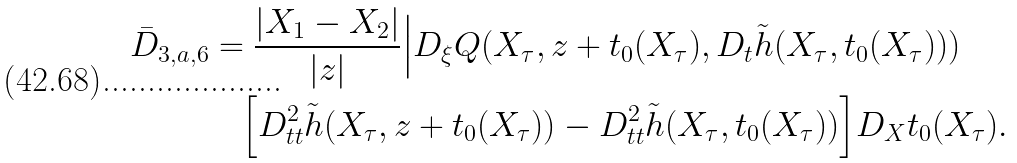Convert formula to latex. <formula><loc_0><loc_0><loc_500><loc_500>\bar { D } _ { 3 , a , 6 } & = \frac { | X _ { 1 } - X _ { 2 } | } { | z | } \Big | D _ { \xi } Q ( X _ { \tau } , z + t _ { 0 } ( X _ { \tau } ) , D _ { t } \tilde { h } ( X _ { \tau } , t _ { 0 } ( X _ { \tau } ) ) ) \\ & \quad \Big [ D ^ { 2 } _ { t t } \tilde { h } ( X _ { \tau } , z + t _ { 0 } ( X _ { \tau } ) ) - D ^ { 2 } _ { t t } \tilde { h } ( X _ { \tau } , t _ { 0 } ( X _ { \tau } ) ) \Big ] D _ { X } t _ { 0 } ( X _ { \tau } ) .</formula> 